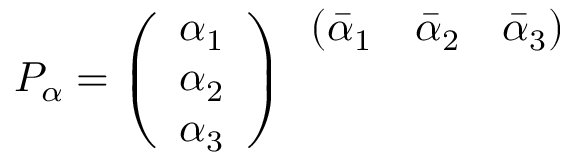<formula> <loc_0><loc_0><loc_500><loc_500>P _ { \alpha } = \left ( \begin{array} { c } { { \alpha _ { 1 } } } \\ { { \alpha _ { 2 } } } \\ { { \alpha _ { 3 } } } \end{array} \right ) \begin{array} { c c c } { { ( \bar { \alpha } _ { 1 } } } & { { \bar { \alpha } _ { 2 } } } & { { \bar { \alpha } _ { 3 } ) } } \end{array}</formula> 